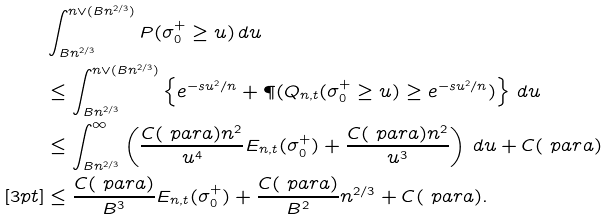Convert formula to latex. <formula><loc_0><loc_0><loc_500><loc_500>& \int _ { B n ^ { 2 / 3 } } ^ { n \vee ( B n ^ { 2 / 3 } ) } P ( \sigma _ { 0 } ^ { + } \geq u ) \, d u \\ & \leq \int _ { B n ^ { 2 / 3 } } ^ { n \vee ( B n ^ { 2 / 3 } ) } \left \{ e ^ { - s u ^ { 2 } / n } + \P ( Q _ { n , t } ( \sigma _ { 0 } ^ { + } \geq u ) \geq e ^ { - s u ^ { 2 } / n } ) \right \} \, d u \\ & \leq \int _ { B n ^ { 2 / 3 } } ^ { \infty } \left ( \frac { C ( \ p a r a ) n ^ { 2 } } { u ^ { 4 } } E _ { n , t } ( \sigma _ { 0 } ^ { + } ) + \frac { C ( \ p a r a ) n ^ { 2 } } { u ^ { 3 } } \right ) \, d u + C ( \ p a r a ) \\ [ 3 p t ] & \leq \frac { C ( \ p a r a ) } { B ^ { 3 } } E _ { n , t } ( \sigma _ { 0 } ^ { + } ) + \frac { C ( \ p a r a ) } { B ^ { 2 } } n ^ { 2 / 3 } + C ( \ p a r a ) .</formula> 